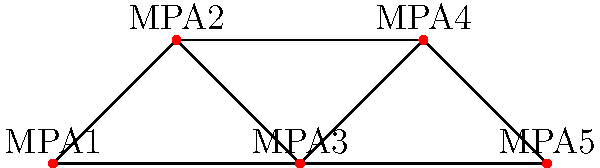In the network diagram of marine protected areas (MPAs) shown above, which MPA has the highest degree centrality, and what is its degree? How might this impact shark conservation efforts? To answer this question, we need to follow these steps:

1. Understand degree centrality:
   Degree centrality is the number of direct connections a node has in a network.

2. Count connections for each MPA:
   MPA1: 2 connections
   MPA2: 3 connections
   MPA3: 4 connections
   MPA4: 2 connections
   MPA5: 1 connection

3. Identify the MPA with the highest degree centrality:
   MPA3 has the highest degree centrality with 4 connections.

4. Consider the impact on shark conservation:
   The MPA with the highest degree centrality (MPA3) is likely to be a crucial hub for shark movement and population connectivity. It may serve as an important area for:
   a) Shark migration routes
   b) Genetic exchange between subpopulations
   c) Potential spillover effects to neighboring areas

5. Conservation implications:
   a) Prioritize protection and enforcement in MPA3
   b) Focus research efforts on understanding shark behavior and ecology in this area
   c) Consider expanding protection to create corridors between MPA3 and connected areas
   d) Use MPA3 as a focal point for regional conservation strategies
Answer: MPA3, degree 4. Critical for shark movement, genetic exchange, and regional conservation efforts. 